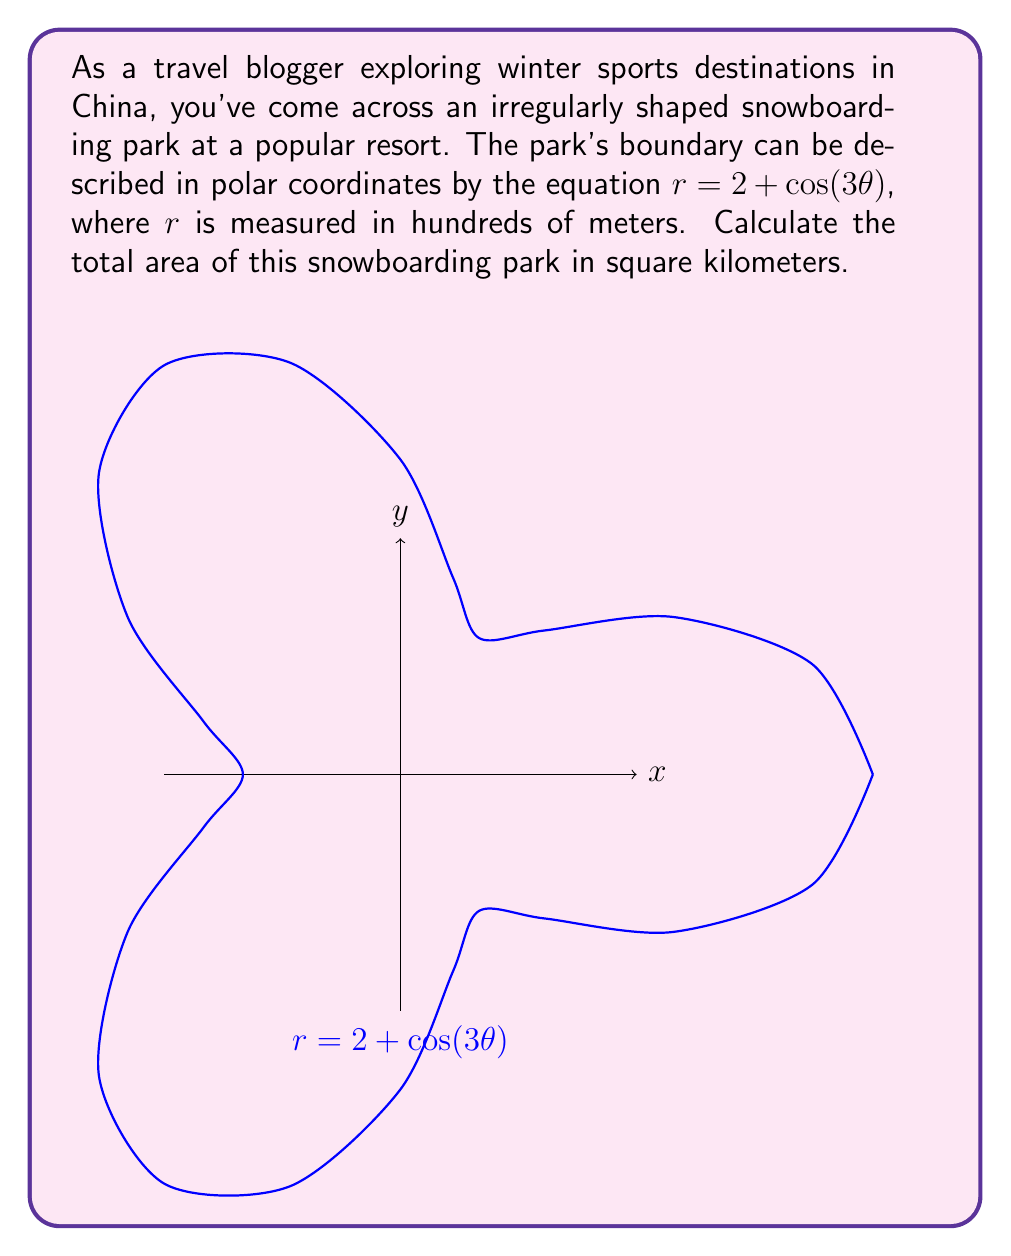Show me your answer to this math problem. To find the area of this irregularly shaped snowboarding park, we'll use the formula for area in polar coordinates:

$$A = \frac{1}{2} \int_{0}^{2\pi} r^2 d\theta$$

where $r = 2 + \cos(3\theta)$

Step 1: Square the radius function
$r^2 = (2 + \cos(3\theta))^2 = 4 + 4\cos(3\theta) + \cos^2(3\theta)$

Step 2: Substitute into the area formula
$$A = \frac{1}{2} \int_{0}^{2\pi} (4 + 4\cos(3\theta) + \cos^2(3\theta)) d\theta$$

Step 3: Integrate term by term
- $\int_{0}^{2\pi} 4 d\theta = 4\theta |_{0}^{2\pi} = 8\pi$
- $\int_{0}^{2\pi} 4\cos(3\theta) d\theta = \frac{4}{3}\sin(3\theta) |_{0}^{2\pi} = 0$
- $\int_{0}^{2\pi} \cos^2(3\theta) d\theta = \frac{1}{2}\int_{0}^{2\pi} (1 + \cos(6\theta)) d\theta = \frac{1}{2}(\theta + \frac{1}{6}\sin(6\theta)) |_{0}^{2\pi} = \pi$

Step 4: Sum up the results
$$A = \frac{1}{2} (8\pi + 0 + \pi) = \frac{9\pi}{2}$$

Step 5: Convert to square kilometers
The radius was measured in hundreds of meters, so we need to multiply by $(100m)^2 = 10000m^2$ and then divide by $1000000m^2/km^2$:

$$A_{km^2} = \frac{9\pi}{2} \cdot \frac{10000}{1000000} = \frac{9\pi}{200} km^2$$
Answer: $\frac{9\pi}{200}$ km² 